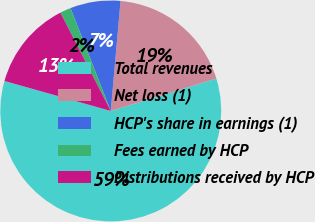Convert chart. <chart><loc_0><loc_0><loc_500><loc_500><pie_chart><fcel>Total revenues<fcel>Net loss (1)<fcel>HCP's share in earnings (1)<fcel>Fees earned by HCP<fcel>Distributions received by HCP<nl><fcel>59.11%<fcel>18.85%<fcel>7.35%<fcel>1.59%<fcel>13.1%<nl></chart> 